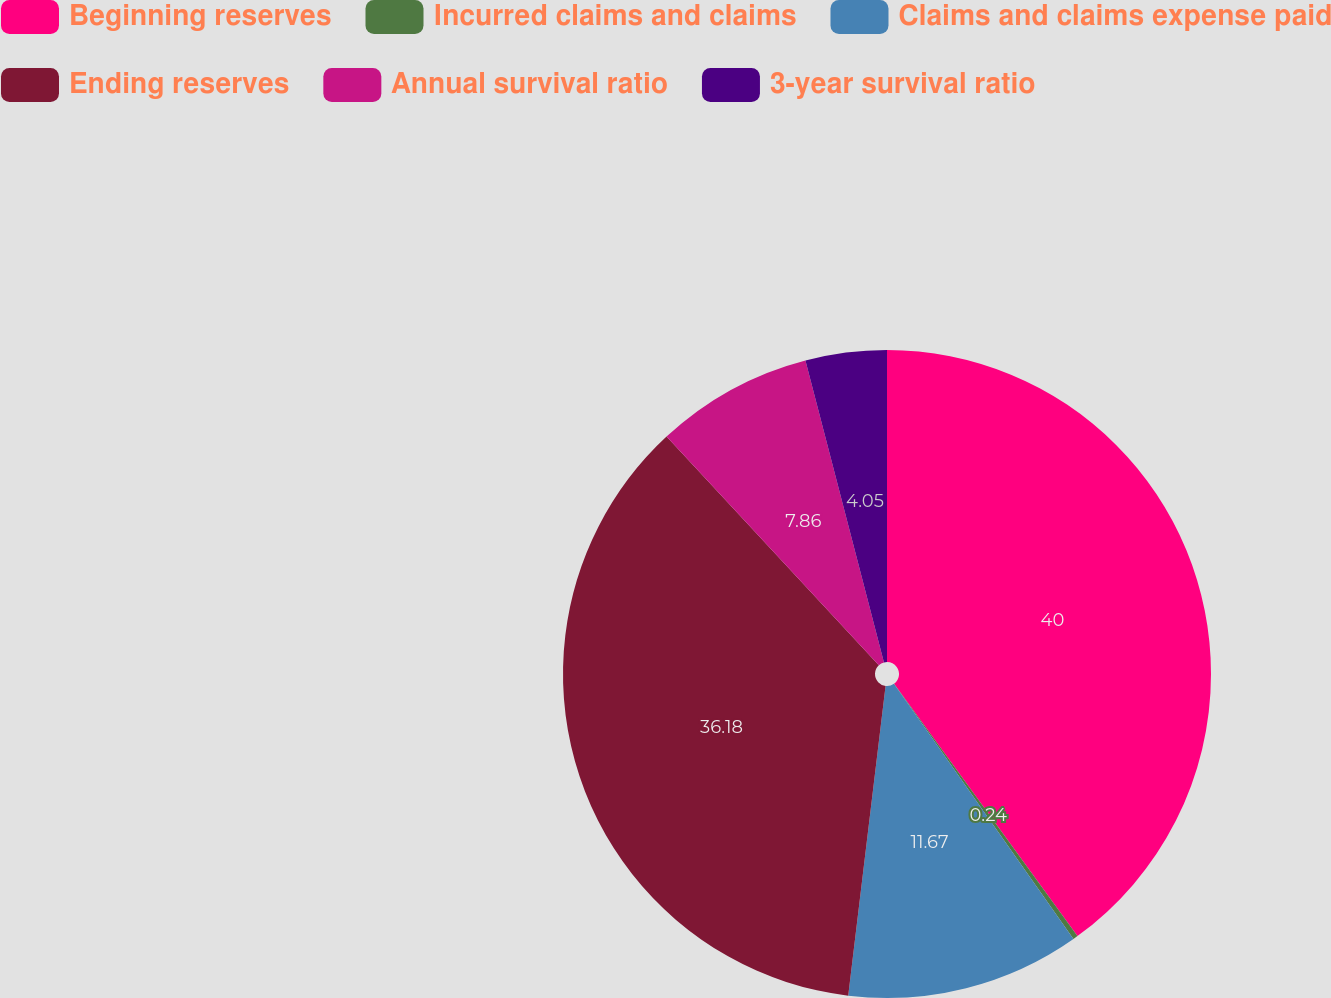<chart> <loc_0><loc_0><loc_500><loc_500><pie_chart><fcel>Beginning reserves<fcel>Incurred claims and claims<fcel>Claims and claims expense paid<fcel>Ending reserves<fcel>Annual survival ratio<fcel>3-year survival ratio<nl><fcel>40.0%<fcel>0.24%<fcel>11.67%<fcel>36.18%<fcel>7.86%<fcel>4.05%<nl></chart> 